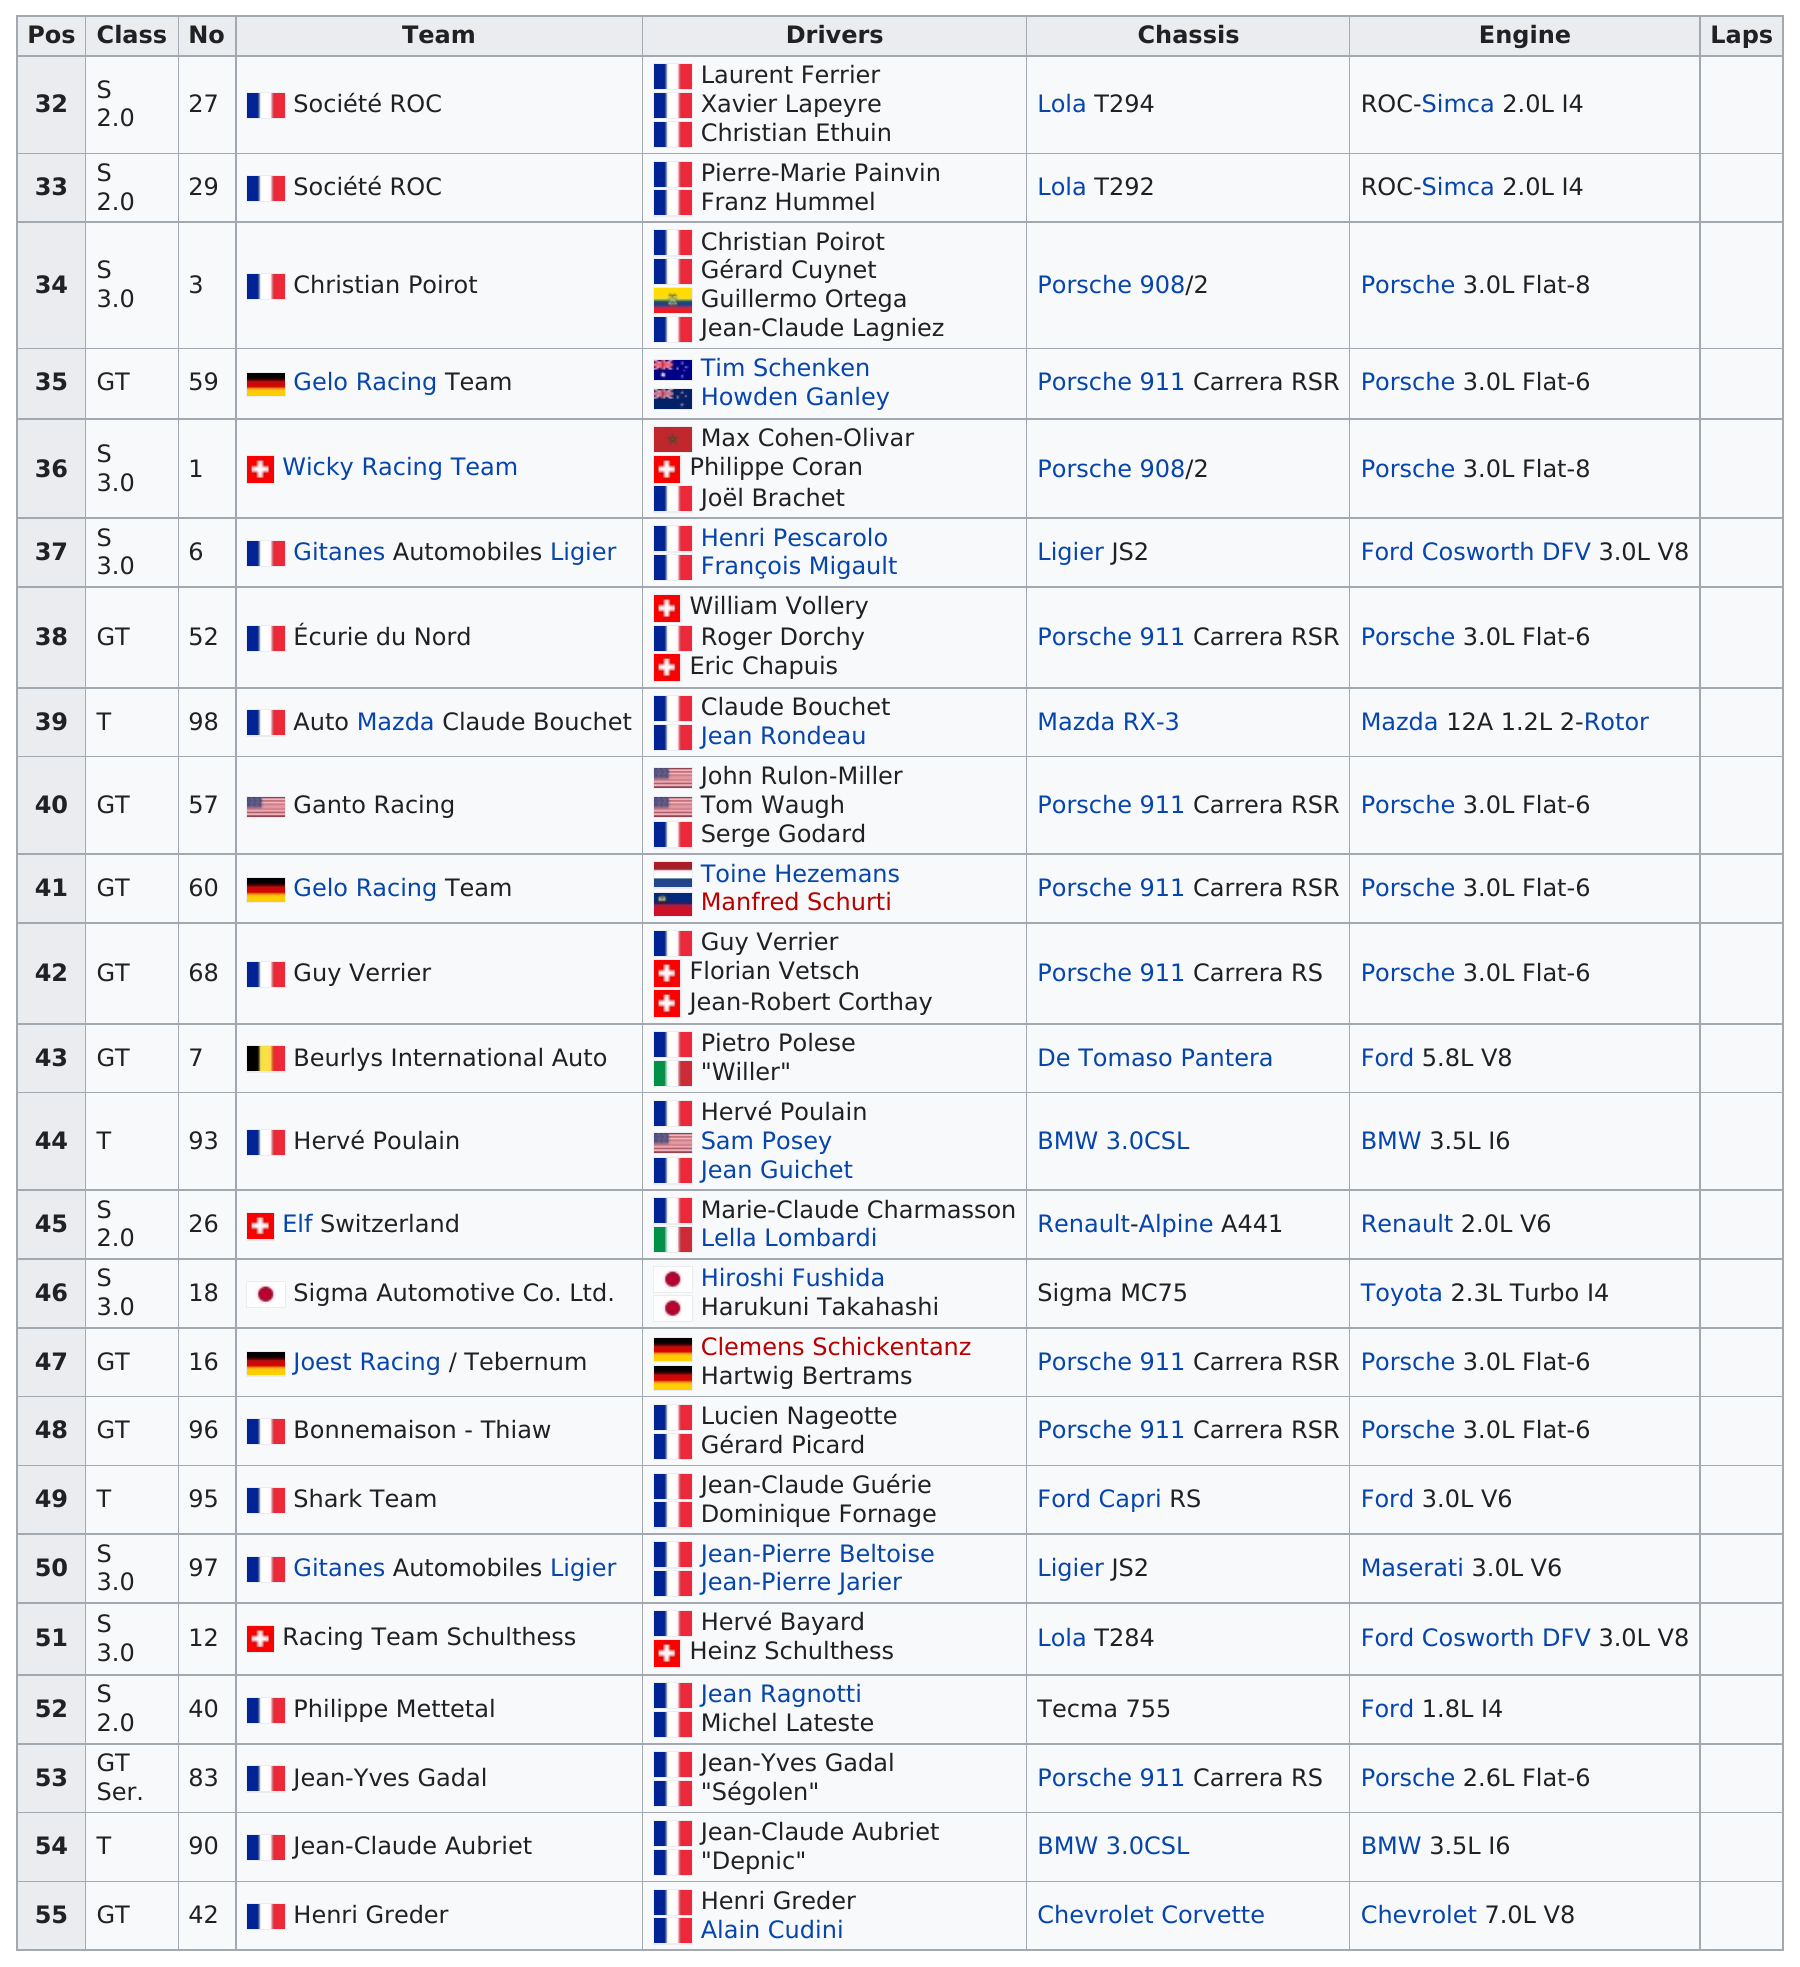Give some essential details in this illustration. The drivers in this race used the Porsche 3.0L Flat-6 engine the most. Both the Gelo Racing Team and the Ecurie du Nord Team utilized the Porsche 911 Carrera RSR chassis in their racing endeavors. France has the most teams on the list. There were five drivers on the Societe ROC team participating in this race. The Porsche 3.0L Flat-6 engine was used by at least three different teams during its usage. 